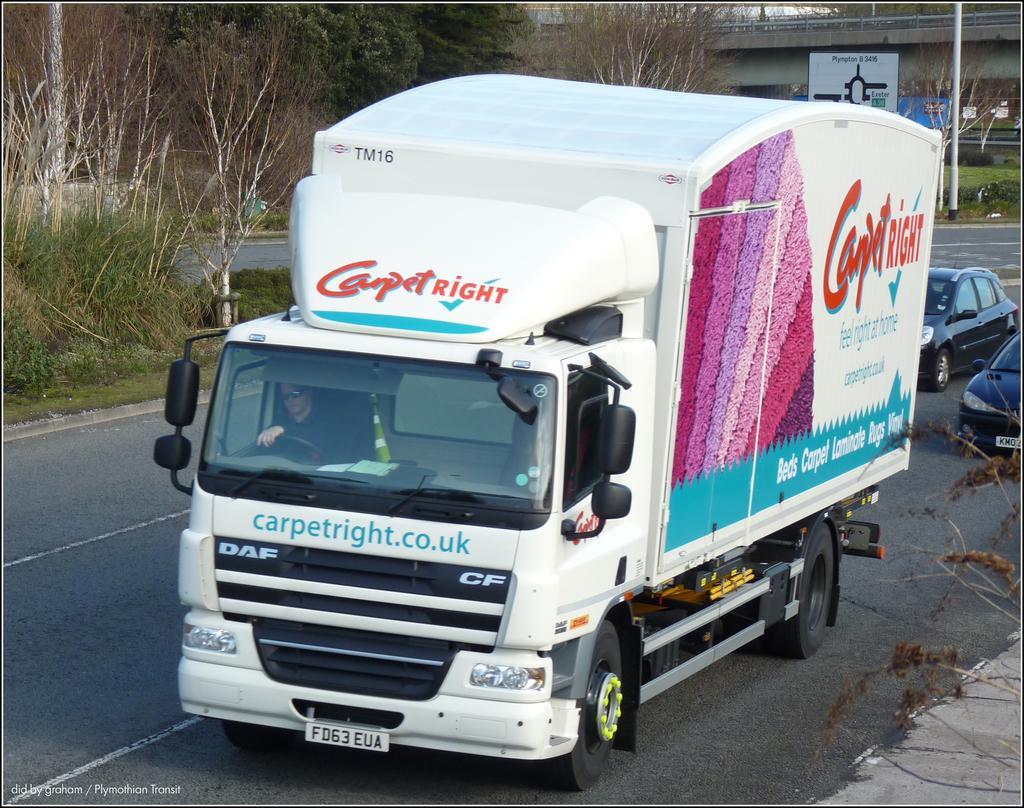How would you summarize this image in a sentence or two? On a road there is a truck and two cars are moving and behind the road there is a bridge and there are few plants around the road. 